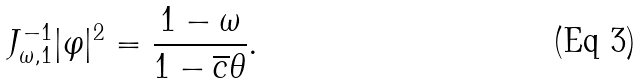<formula> <loc_0><loc_0><loc_500><loc_500>J _ { \omega , 1 } ^ { - 1 } | \varphi | ^ { 2 } = \frac { 1 - \omega } { 1 - \overline { c } \theta } .</formula> 